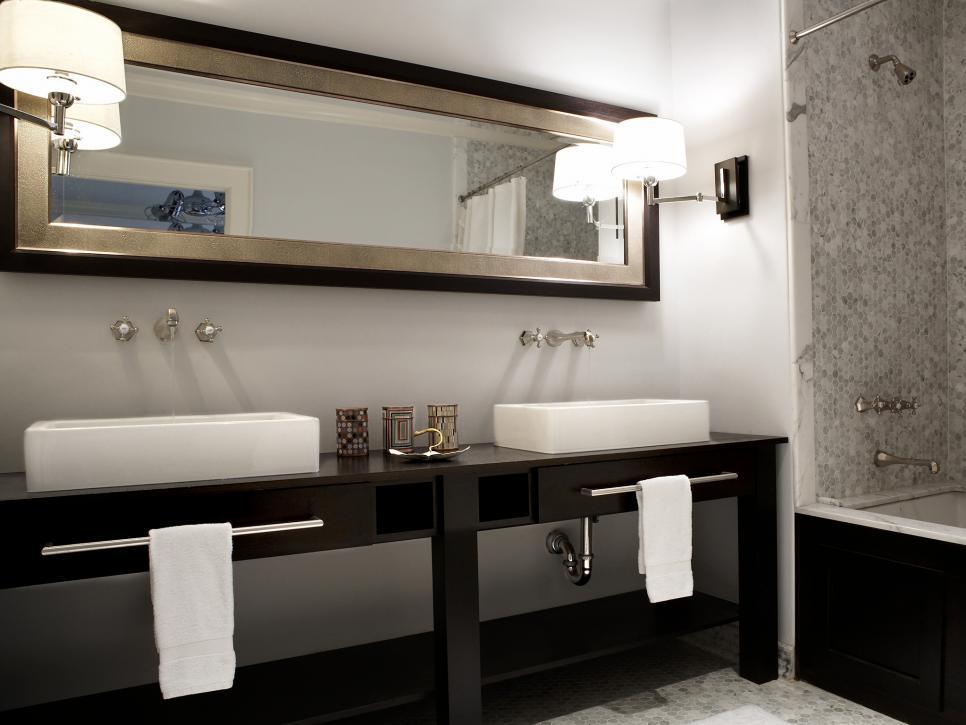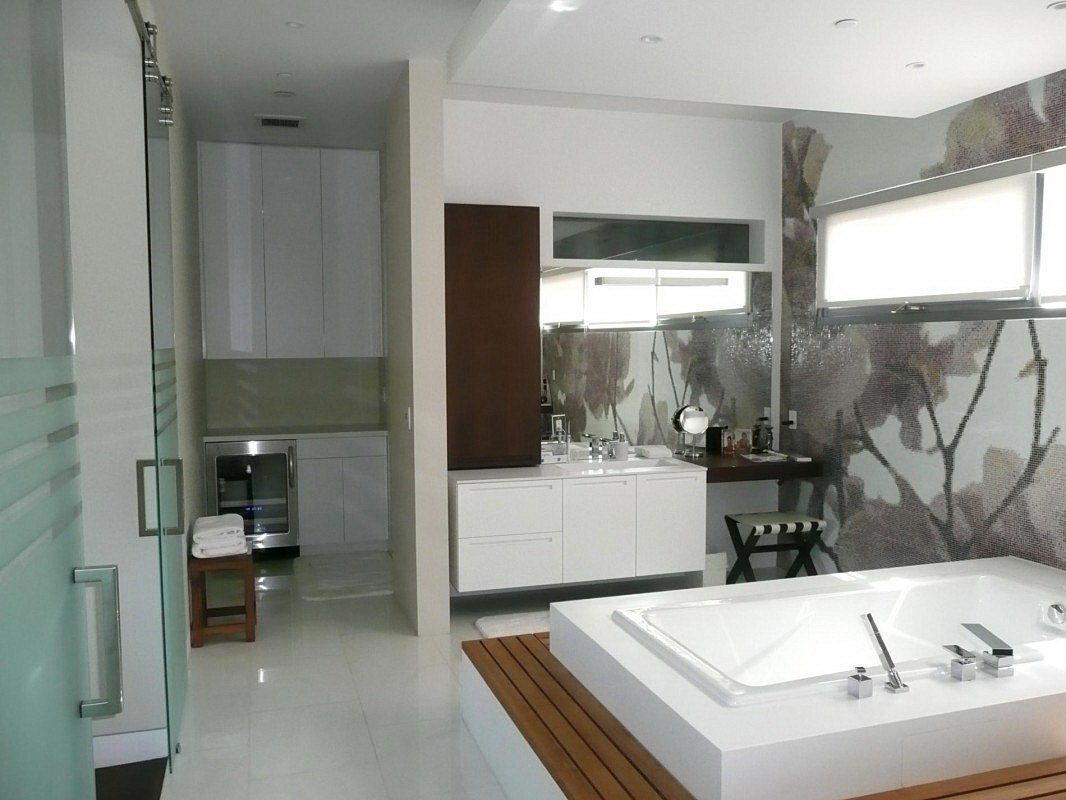The first image is the image on the left, the second image is the image on the right. Analyze the images presented: Is the assertion "The right image shows a vanity with two gooseneck type faucets that curve downward." valid? Answer yes or no. No. The first image is the image on the left, the second image is the image on the right. For the images shown, is this caption "In one image, matching rectangular white sinks are placed on top of side-by-side vanities." true? Answer yes or no. Yes. 